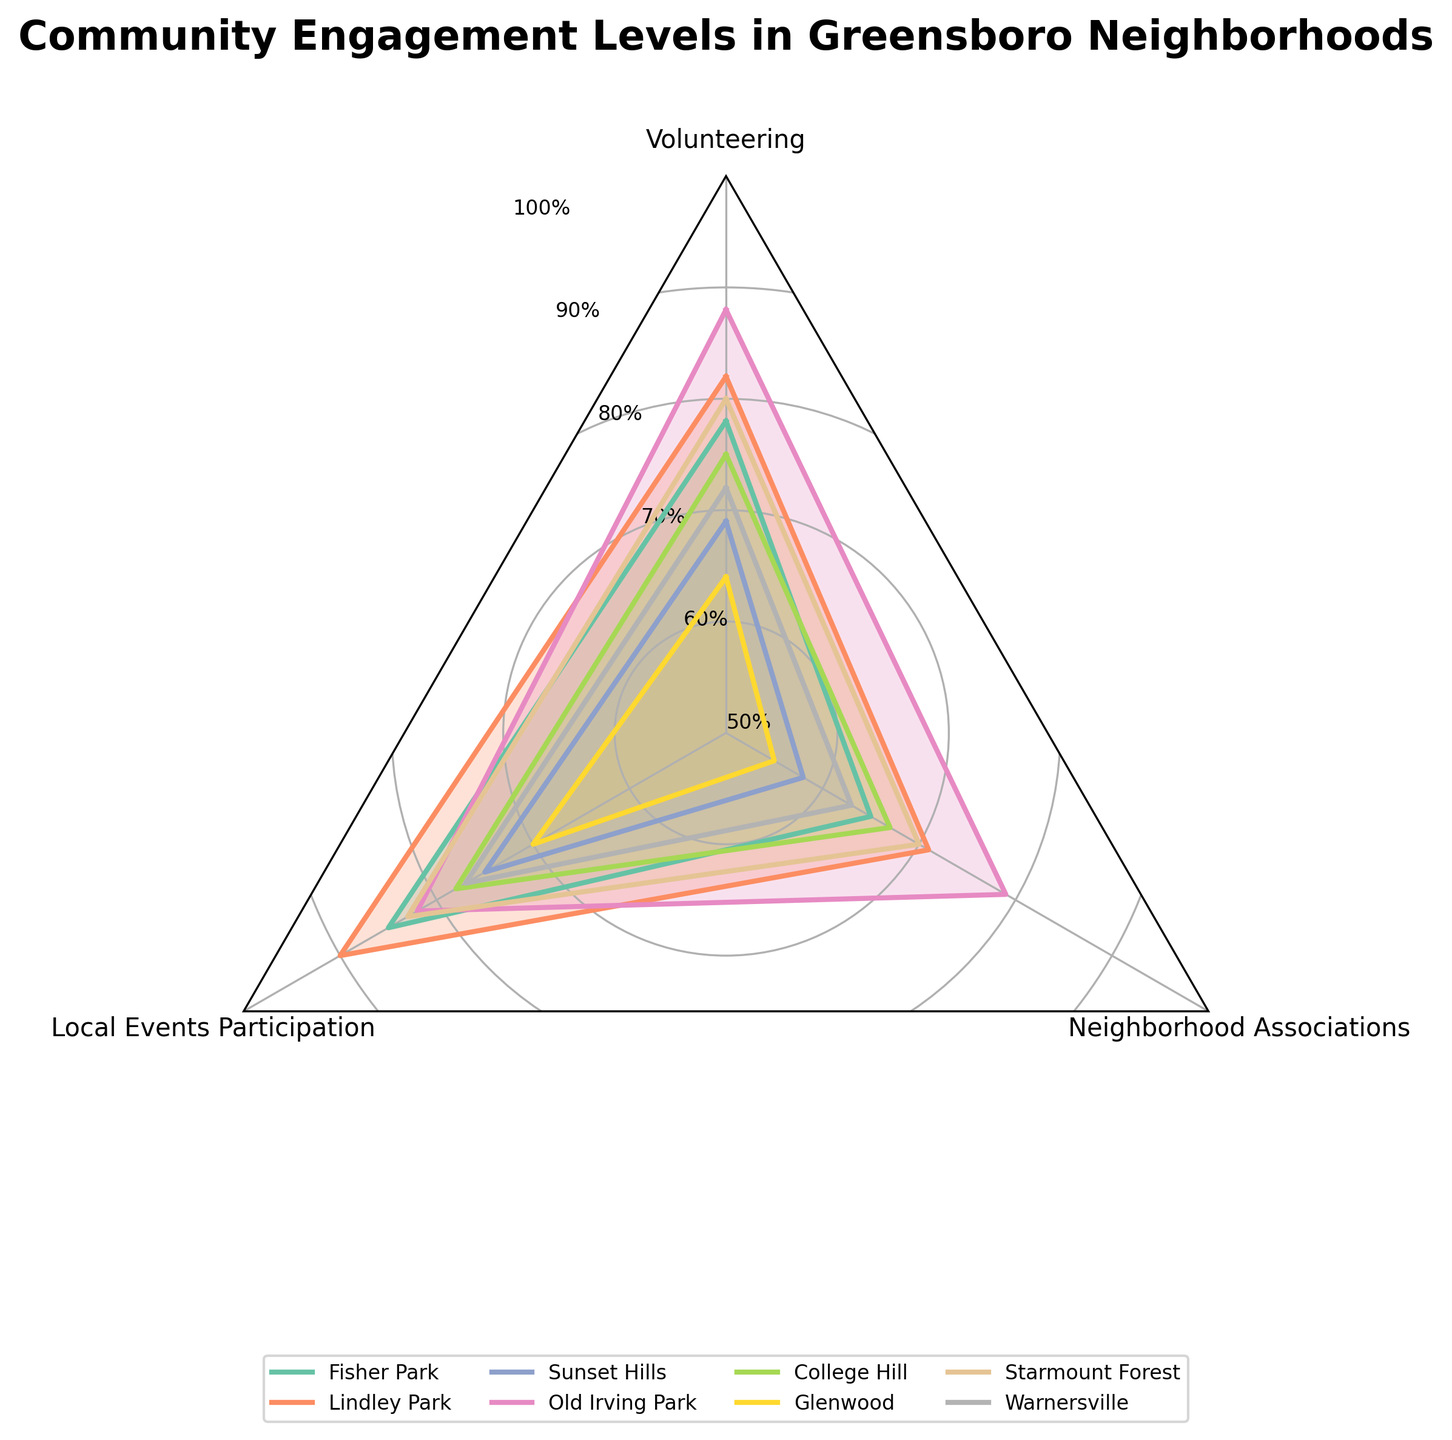Which neighborhood has the highest level of volunteering? The radar chart shows the percentage levels of volunteering for each neighborhood. Observing the plot, Old Irving Park has the highest volunteering percentage at 88%.
Answer: Old Irving Park Which neighborhood has the lowest participation in local events? By examining the radar chart, it's clear that Glenwood has the lowest level of local events participation at 70%.
Answer: Glenwood What is the average neighborhood association engagement level for College Hill and Sunset Hills? The neighborhood association levels are 67% for College Hill and 58% for Sunset Hills. The average is calculated as (67 + 58) / 2 = 125 / 2 = 62.5%.
Answer: 62.5% Compare the volunteering levels between Fisher Park and Starmount Forest. Which one is higher? The radar chart shows that Fisher Park has a volunteering level of 78%, while Starmount Forest has 80%. Starmount Forest is higher.
Answer: Starmount Forest How does Warnersville compare to Glenwood in terms of local event participation? Warnersville has 77% local events participation, while Glenwood has 70%, making Warnersville higher by 7 percentage points.
Answer: Warnersville is higher Which neighborhood shows the most balanced engagement across all three activities analyzed? Observing the radar chart, Old Irving Park has relatively high and balanced levels across all three categories: Volunteering (88%), Local Events Participation (82%), and Neighborhood Associations (79%).
Answer: Old Irving Park What is the ranking of neighborhoods based on neighborhood association involvement from highest to lowest? By inspecting the radar chart, the ranks are Old Irving Park (79%), Lindley Park (71%), Starmount Forest (70%), College Hill (67%), Fisher Park (65%), Warnersville (63%), Sunset Hills (58%), and Glenwood (55%).
Answer: Old Irving Park, Lindley Park, Starmount Forest, College Hill, Fisher Park, Warnersville, Sunset Hills, Glenwood Calculate the difference in volunteering levels between Lindley Park and Glenwood. Lindley Park has a volunteering level of 82%, and Glenwood has 64%. The difference is 82% - 64% = 18%.
Answer: 18% Which neighborhood has the most significant disparity between any two engagement levels? By examining the radar chart, Glenwood exhibits the largest disparity between local events participation (70%) and neighborhood associations (55%), with a difference of 15 percentage points.
Answer: Glenwood What is the median value of local events participation across all neighborhoods? Listing all local events participation values (70%, 75%, 77%, 78%, 82%, 83%, 85%, 90%) and finding the middle values (78% and 82%), the median is (78 + 82) / 2 = 80%.
Answer: 80% 